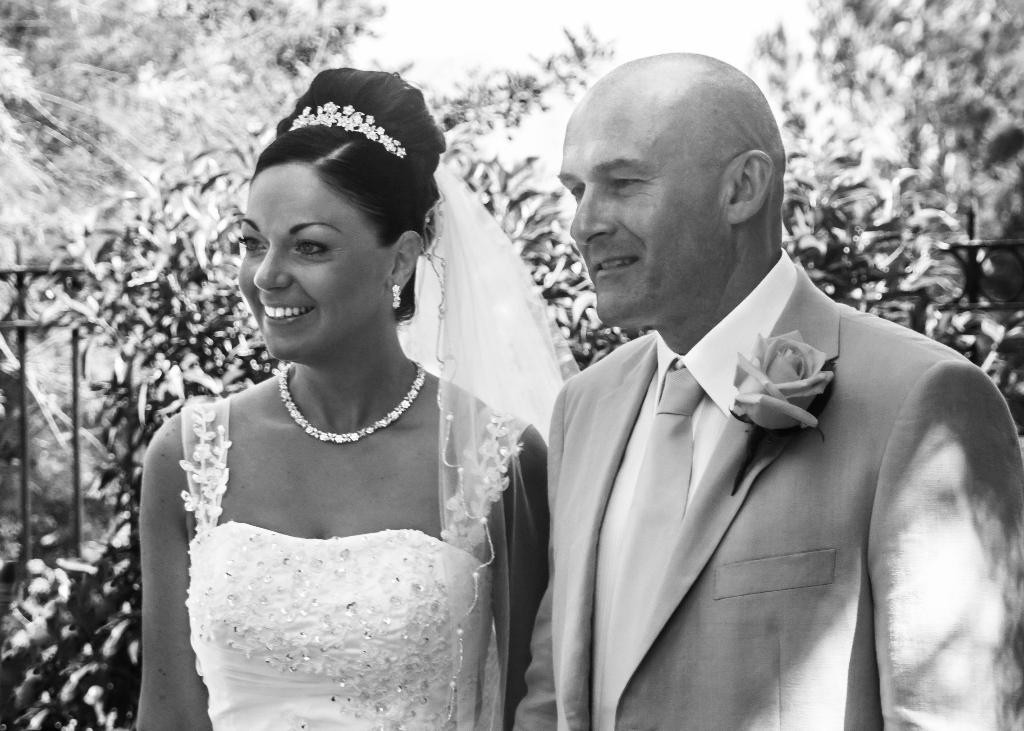How many people are present in the image? There are two people in the image. What is the facial expression of the people in the image? The people are smiling. Can you describe any objects visible in the image? There are objects in the image, but their specific nature is not mentioned in the facts. What can be seen in the background of the image? There is a fence and trees in the background of the image. How many snakes are slithering around the people in the image? There are no snakes present in the image; the people are smiling and there are objects and a fence in the background. 